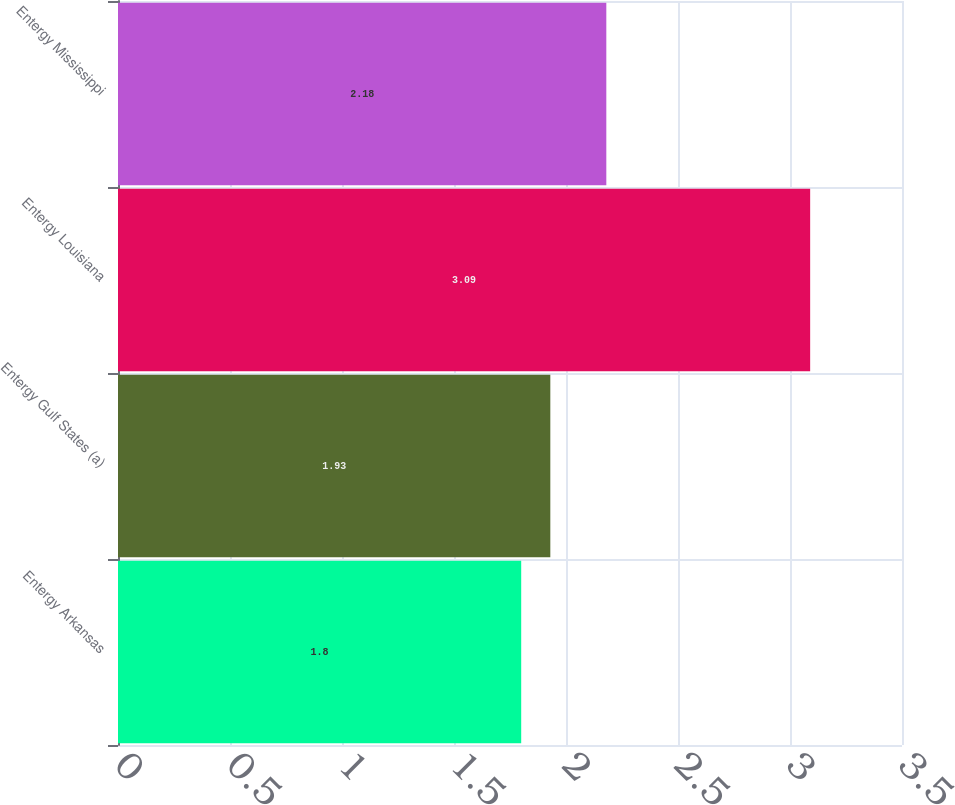Convert chart to OTSL. <chart><loc_0><loc_0><loc_500><loc_500><bar_chart><fcel>Entergy Arkansas<fcel>Entergy Gulf States (a)<fcel>Entergy Louisiana<fcel>Entergy Mississippi<nl><fcel>1.8<fcel>1.93<fcel>3.09<fcel>2.18<nl></chart> 